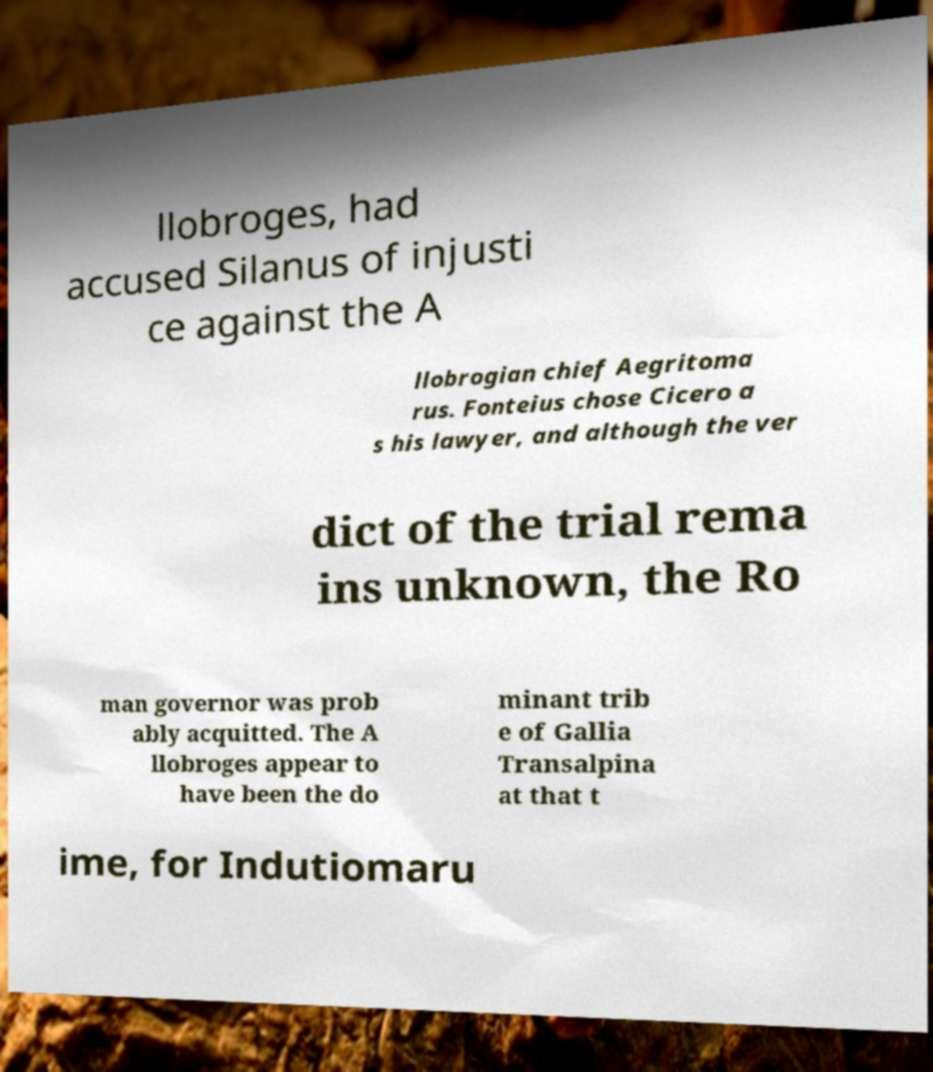Please identify and transcribe the text found in this image. llobroges, had accused Silanus of injusti ce against the A llobrogian chief Aegritoma rus. Fonteius chose Cicero a s his lawyer, and although the ver dict of the trial rema ins unknown, the Ro man governor was prob ably acquitted. The A llobroges appear to have been the do minant trib e of Gallia Transalpina at that t ime, for Indutiomaru 